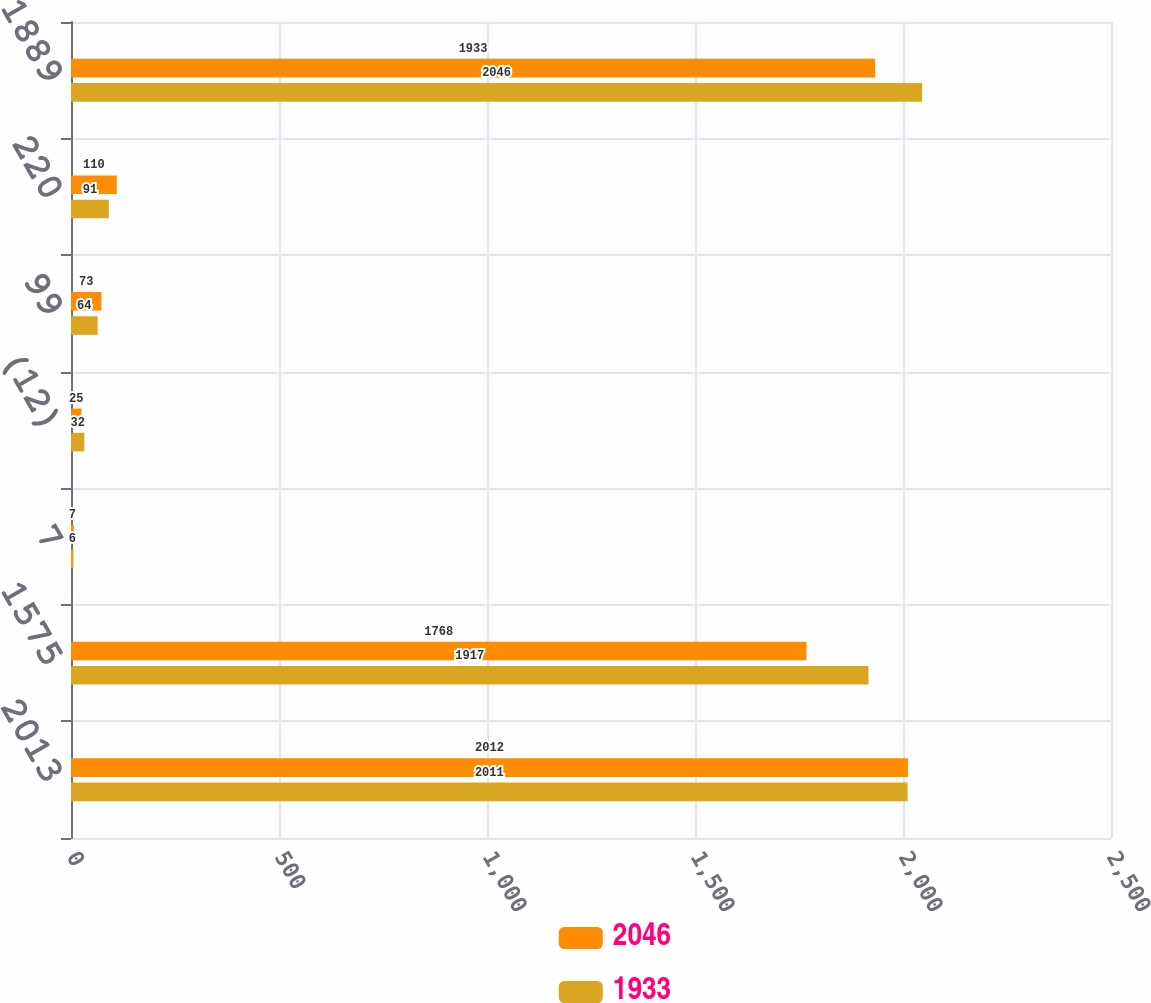<chart> <loc_0><loc_0><loc_500><loc_500><stacked_bar_chart><ecel><fcel>2013<fcel>1575<fcel>7<fcel>(12)<fcel>99<fcel>220<fcel>1889<nl><fcel>2046<fcel>2012<fcel>1768<fcel>7<fcel>25<fcel>73<fcel>110<fcel>1933<nl><fcel>1933<fcel>2011<fcel>1917<fcel>6<fcel>32<fcel>64<fcel>91<fcel>2046<nl></chart> 